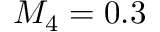<formula> <loc_0><loc_0><loc_500><loc_500>M _ { 4 } = 0 . 3</formula> 